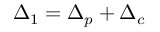<formula> <loc_0><loc_0><loc_500><loc_500>{ \Delta _ { 1 } } = { \Delta _ { p } } + { \Delta _ { c } }</formula> 